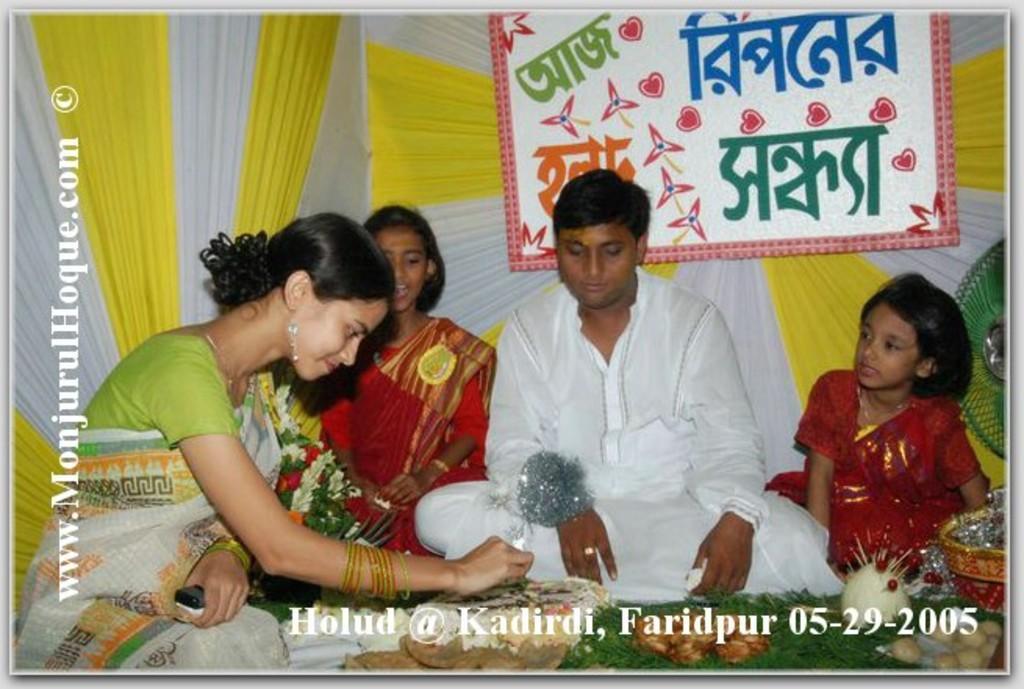Describe this image in one or two sentences. There is a group of persons sitting in the middle of this image, and there is a curtain in the background. There is a watermark on the left side of this image and at the bottom of this image as well. There is a board attached to the curtain as we can see at the top of this image. 